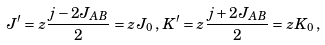Convert formula to latex. <formula><loc_0><loc_0><loc_500><loc_500>J ^ { \prime } = z \frac { j - 2 J _ { A B } } { 2 } = z J _ { 0 } \, , \, K ^ { \prime } = z \frac { j + 2 J _ { A B } } { 2 } = z K _ { 0 } \, ,</formula> 